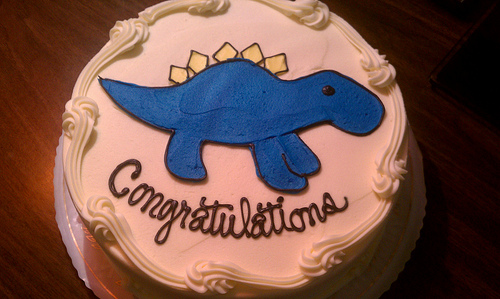<image>
Is there a dino on the cake? Yes. Looking at the image, I can see the dino is positioned on top of the cake, with the cake providing support. 